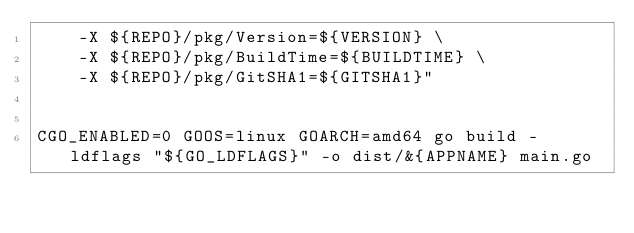Convert code to text. <code><loc_0><loc_0><loc_500><loc_500><_Bash_>    -X ${REPO}/pkg/Version=${VERSION} \
    -X ${REPO}/pkg/BuildTime=${BUILDTIME} \
    -X ${REPO}/pkg/GitSHA1=${GITSHA1}"


CGO_ENABLED=0 GOOS=linux GOARCH=amd64 go build -ldflags "${GO_LDFLAGS}" -o dist/&{APPNAME} main.go</code> 